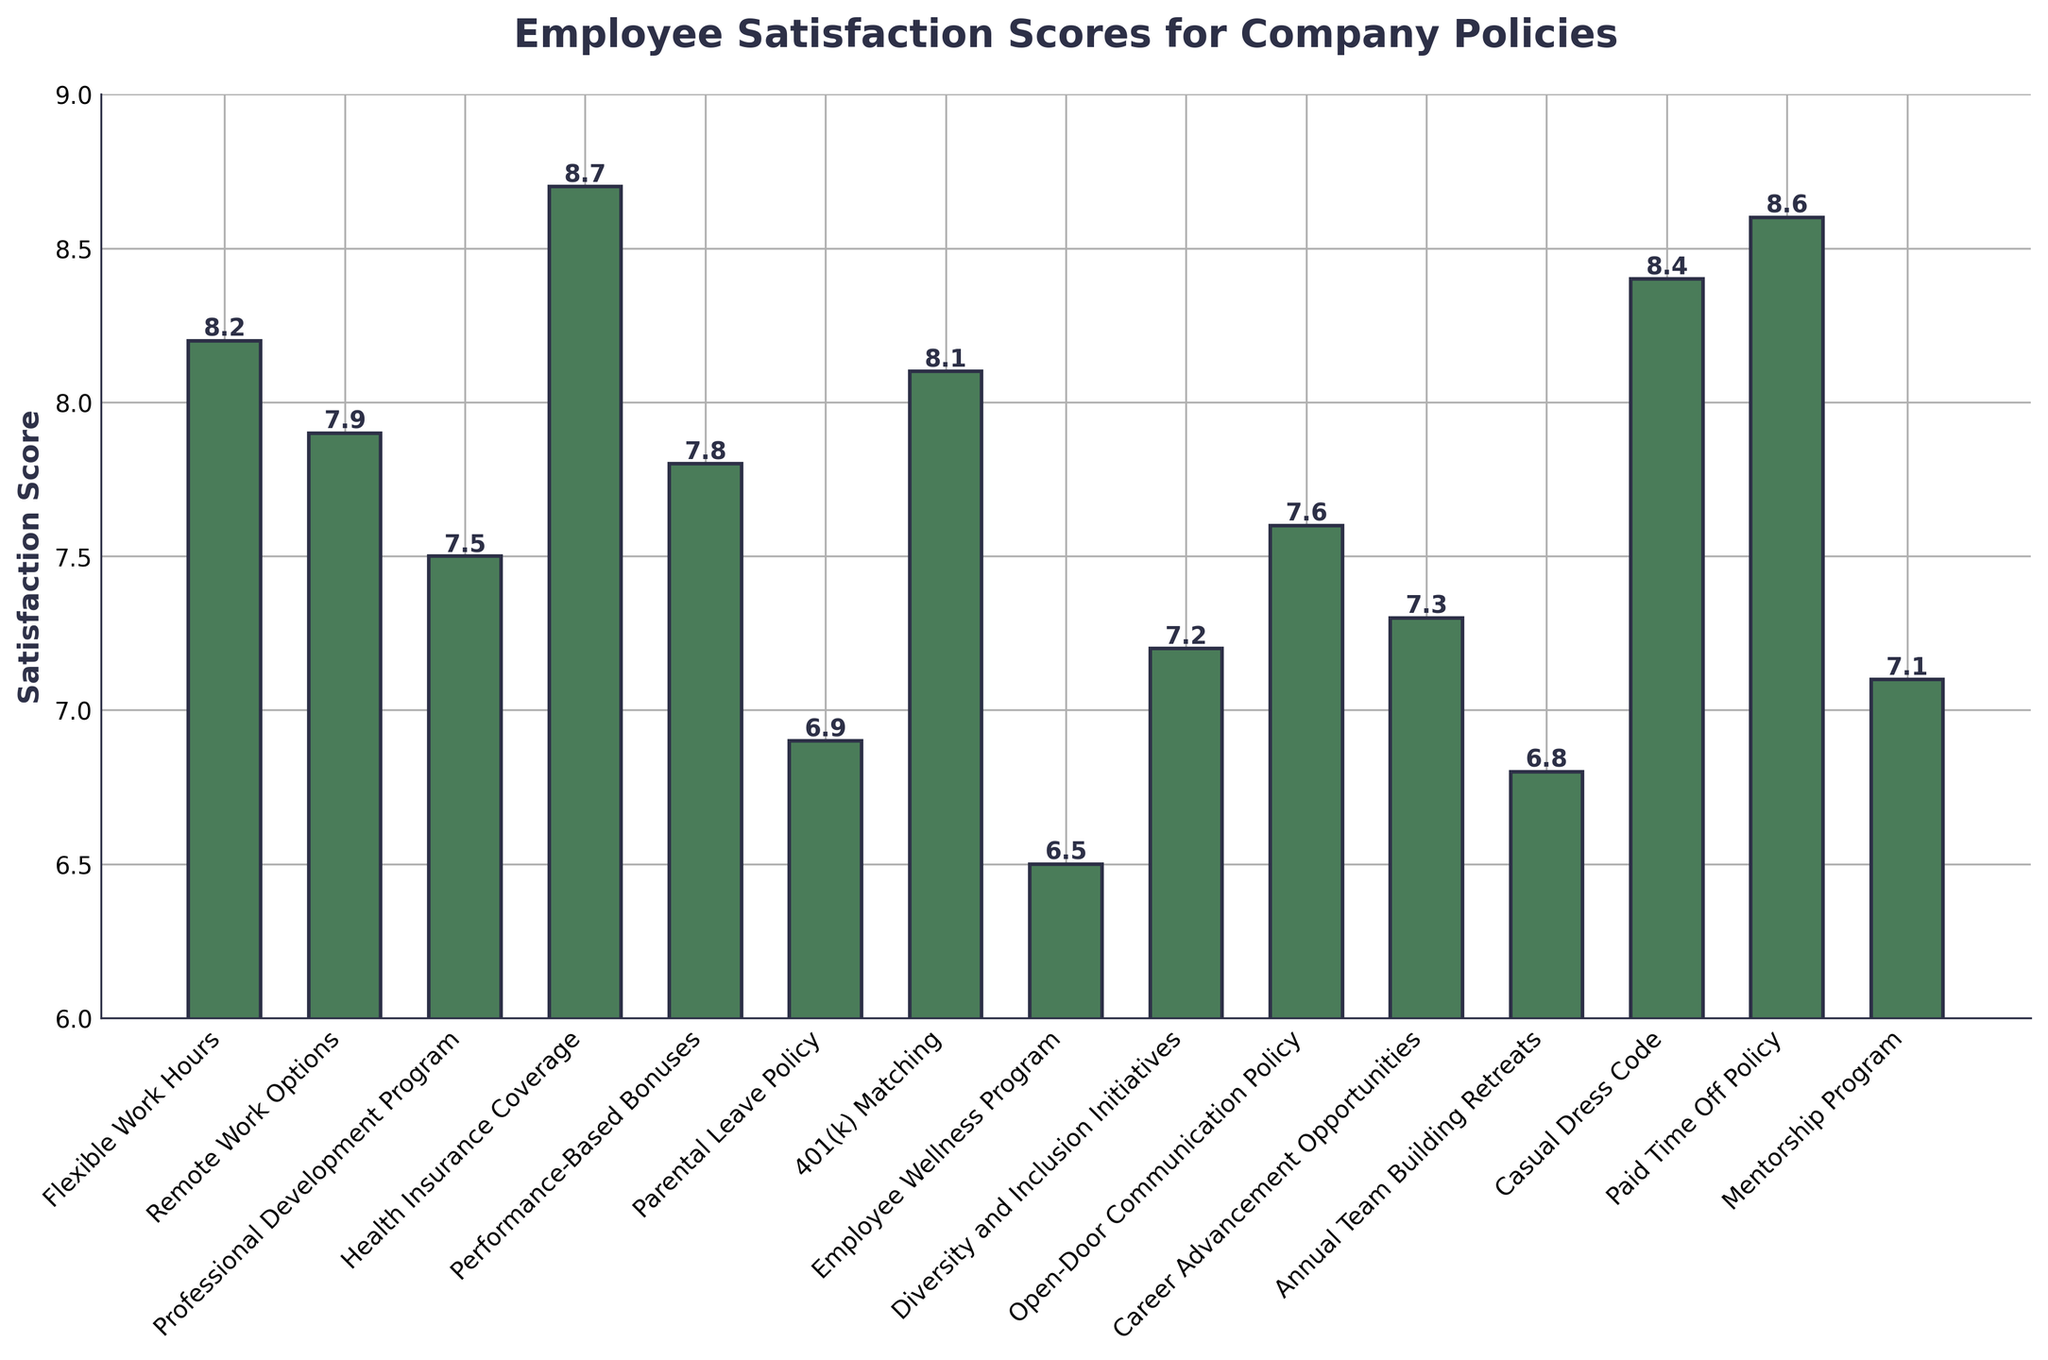Which company policy has the highest employee satisfaction score? The policy with the highest bar in the chart represents the policy with the highest satisfaction score. By viewing the heights of all bars, Health Insurance Coverage has the highest score.
Answer: Health Insurance Coverage Which two policies are tied with the highest satisfaction scores? Look for the highest satisfaction score among all policies and see if more than one policy has the same score. Health Insurance Coverage (8.7) has the highest score and no other policy has the same score, so it is not tied. The next highest scores are for Paid Time Off Policy with 8.6 and Casual Dress Code with 8.4, but they're not tied either.
Answer: None What is the difference in satisfaction scores between the Health Insurance Coverage and the Parental Leave Policy? Subtract the satisfaction score of the Parental Leave Policy from that of the Health Insurance Coverage. Health Insurance Coverage is 8.7, Parental Leave Policy is 6.9. The difference is 8.7 - 6.9.
Answer: 1.8 What is the average satisfaction score of the policies with a score higher than 8? Identify the policies with scores higher than 8, then sum these scores and divide by the number of policies. Policies with scores higher than 8 are Health Insurance Coverage (8.7), Flexible Work Hours (8.2), 401(k) Matching (8.1), Casual Dress Code (8.4), Paid Time Off Policy (8.6). The sum is 8.7 + 8.2 + 8.1 + 8.4 + 8.6 = 42. Divide by the number of policies (5): 42 / 5 = 8.4.
Answer: 8.4 Which policy has the lowest satisfaction score and what is that score? Find the shortest bar in the chart to identify the policy with the lowest satisfaction score. The shortest bar corresponds to the Employee Wellness Program with a score of 6.5.
Answer: Employee Wellness Program, 6.5 How many policies have a satisfaction score lower than 7.5? Count the bars that represent satisfaction scores below 7.5. The policies are Parental Leave Policy (6.9), Employee Wellness Program (6.5), Annual Team Building Retreats (6.8), and Diversity and Inclusion Initiatives (7.2). There are 4 such policies.
Answer: 4 What is the sum of the satisfaction scores for the Professional Development Program and the Mentorship Program? Add the satisfaction scores of the Professional Development Program and the Mentorship Program. Professional Development Program is 7.5 and Mentorship Program is 7.1. Sum is 7.5 + 7.1.
Answer: 14.6 Rank the policies from highest to lowest satisfaction scores. Arrange the policies according to their satisfaction scores in descending order. Health Insurance Coverage (8.7), Paid Time Off Policy (8.6), Casual Dress Code (8.4), Flexible Work Hours (8.2), 401(k) Matching (8.1), Remote Work Options (7.9), Performance-Based Bonuses (7.8), Open-Door Communication Policy (7.6), Professional Development Program (7.5), Career Advancement Opportunities (7.3), Diversity and Inclusion Initiatives (7.2), Mentorship Program (7.1), Parental Leave Policy (6.9), Annual Team Building Retreats (6.8), Employee Wellness Program (6.5).
Answer: Health Insurance Coverage, Paid Time Off Policy, Casual Dress Code, Flexible Work Hours, 401(k) Matching, Remote Work Options, Performance-Based Bonuses, Open-Door Communication Policy, Professional Development Program, Career Advancement Opportunities, Diversity and Inclusion Initiatives, Mentorship Program, Parental Leave Policy, Annual Team Building Retreats, Employee Wellness Program 